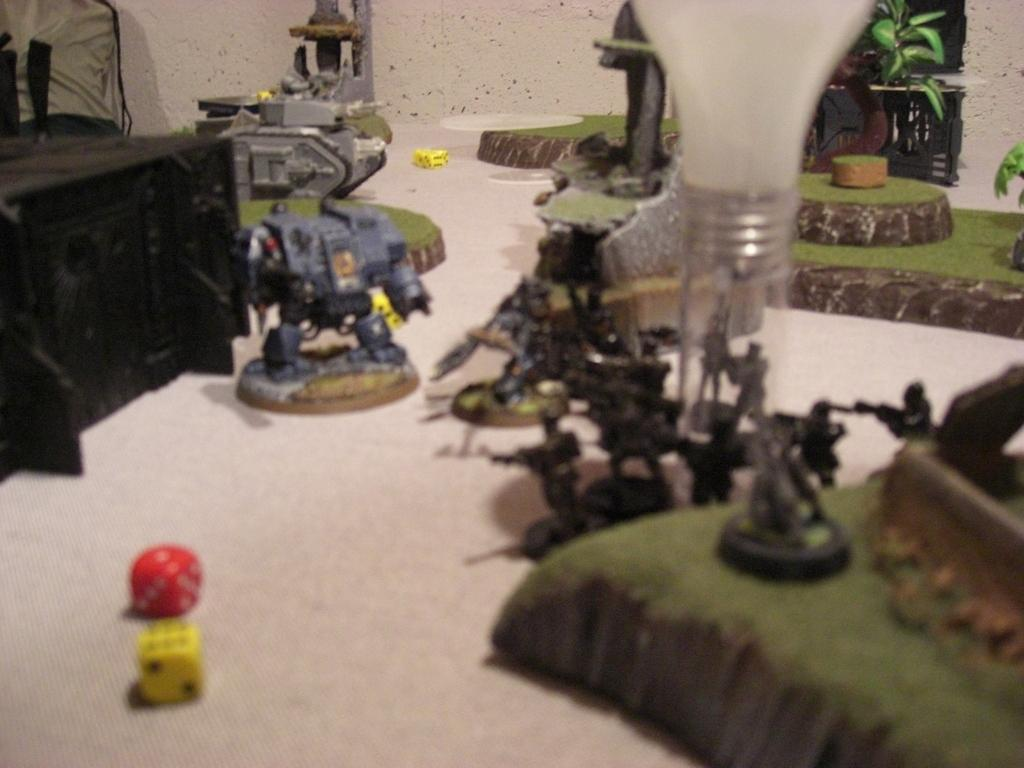What can be seen in abundance in the image? There are many toys in the image. Can you describe the object on the left side of the image? There is a black color object on the left side of the image. What type of bucket is being used to attack the toys in the image? There is no bucket or attack present in the image; it only features toys and a black color object. 